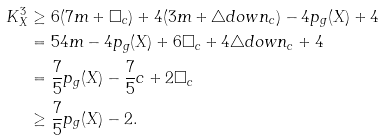Convert formula to latex. <formula><loc_0><loc_0><loc_500><loc_500>K _ { X } ^ { 3 } & \geq 6 ( 7 m + \Box _ { c } ) + 4 ( 3 m + \triangle d o w n _ { c } ) - 4 p _ { g } ( X ) + 4 \\ & = 5 4 m - 4 p _ { g } ( X ) + 6 \Box _ { c } + 4 \triangle d o w n _ { c } + 4 \\ & = \frac { 7 } { 5 } p _ { g } ( X ) - \frac { 7 } { 5 } c + 2 \Box _ { c } \\ & \geq \frac { 7 } { 5 } p _ { g } ( X ) - 2 .</formula> 